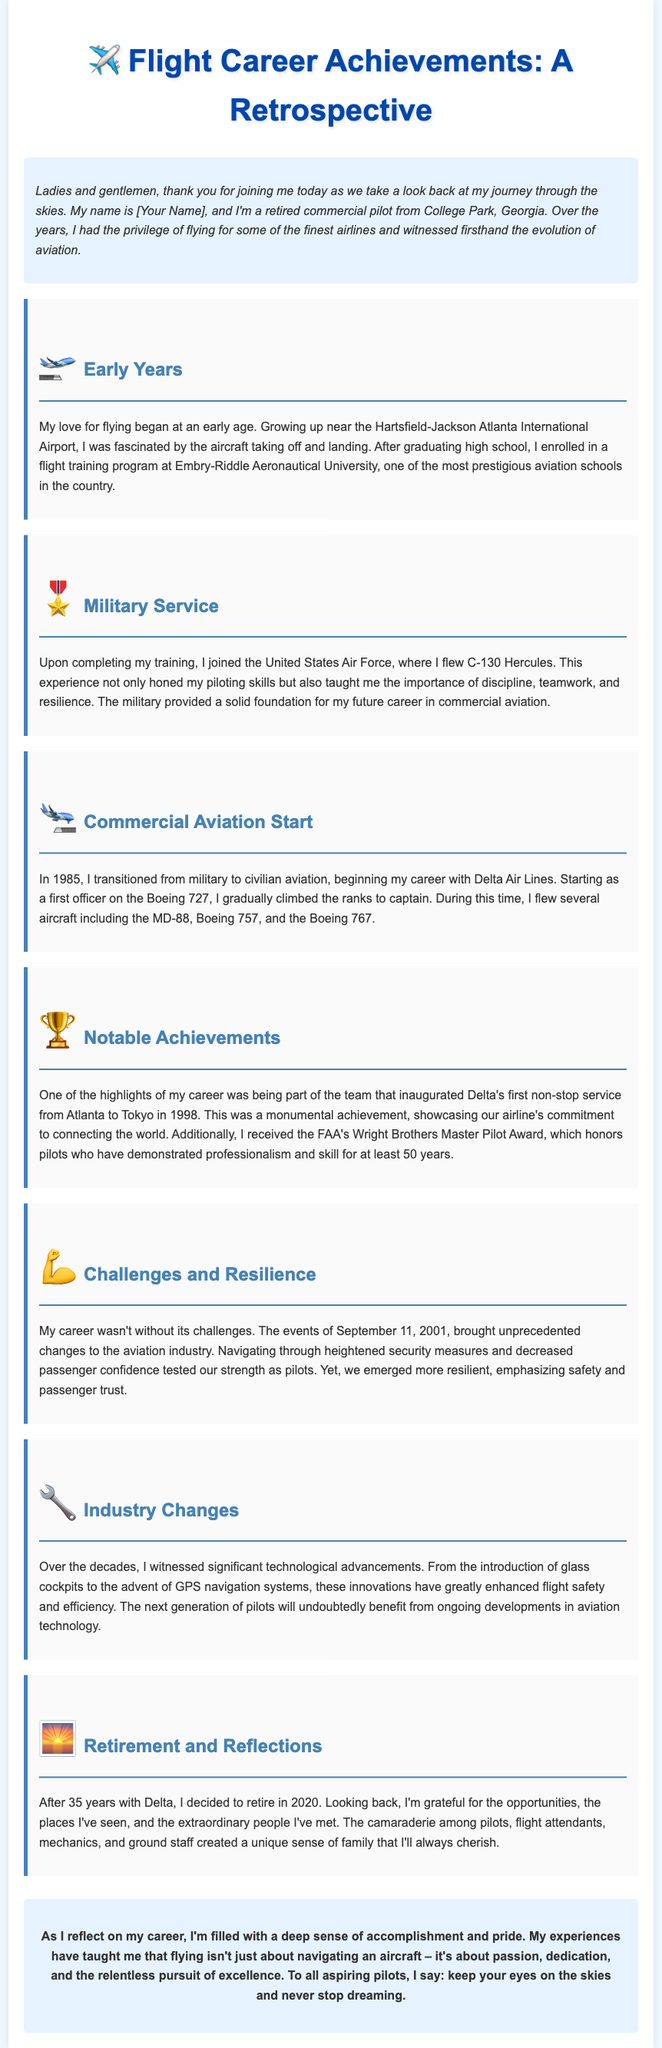what was the pilot's first commercial airline? The pilot began his career with Delta Air Lines.
Answer: Delta Air Lines in which year did the pilot retire? The pilot retired in 2020 after 35 years with Delta.
Answer: 2020 what prestigious aviation school did the pilot attend? The pilot enrolled in a flight training program at Embry-Riddle Aeronautical University.
Answer: Embry-Riddle Aeronautical University which aircraft did the pilot fly as a first officer? The pilot started as a first officer on the Boeing 727.
Answer: Boeing 727 what award did the pilot receive for professionalism and skill? The pilot received the FAA's Wright Brothers Master Pilot Award.
Answer: Wright Brothers Master Pilot Award how many years did the pilot serve in his career before retirement? The pilot's career spanned 35 years with Delta.
Answer: 35 years which military aircraft did the pilot fly? The pilot flew the C-130 Hercules during his military service.
Answer: C-130 Hercules what was one of the significant changes in the aviation industry mentioned? The events of September 11, 2001, brought unprecedented changes to aviation.
Answer: September 11, 2001 what significant route did the pilot participate in inaugurating? The pilot was part of the team that inaugurated Delta's first non-stop service from Atlanta to Tokyo.
Answer: Atlanta to Tokyo 